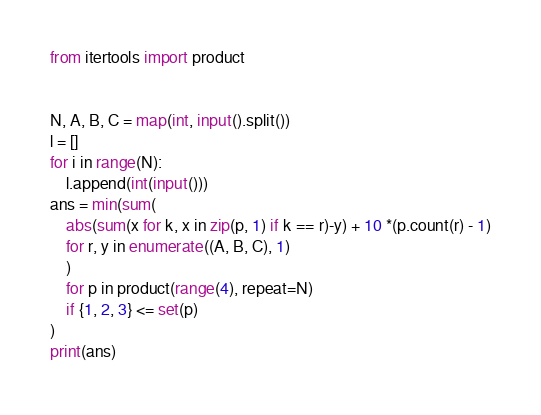<code> <loc_0><loc_0><loc_500><loc_500><_Python_>from itertools import product


N, A, B, C = map(int, input().split())
l = []
for i in range(N):
    l.append(int(input()))
ans = min(sum(
    abs(sum(x for k, x in zip(p, 1) if k == r)-y) + 10 *(p.count(r) - 1)
    for r, y in enumerate((A, B, C), 1)
    )
    for p in product(range(4), repeat=N)
    if {1, 2, 3} <= set(p)
)
print(ans)</code> 